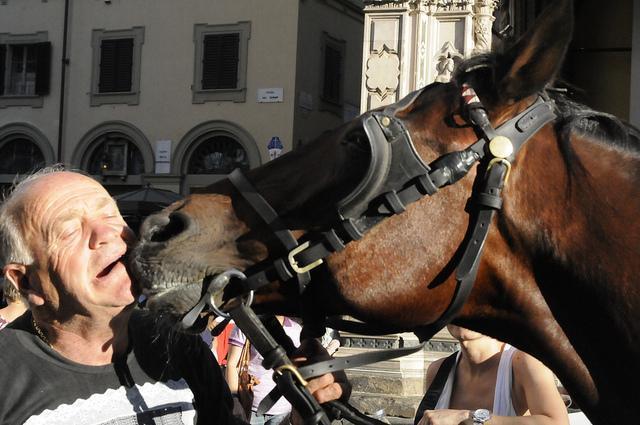How many people are in the photo?
Give a very brief answer. 3. 